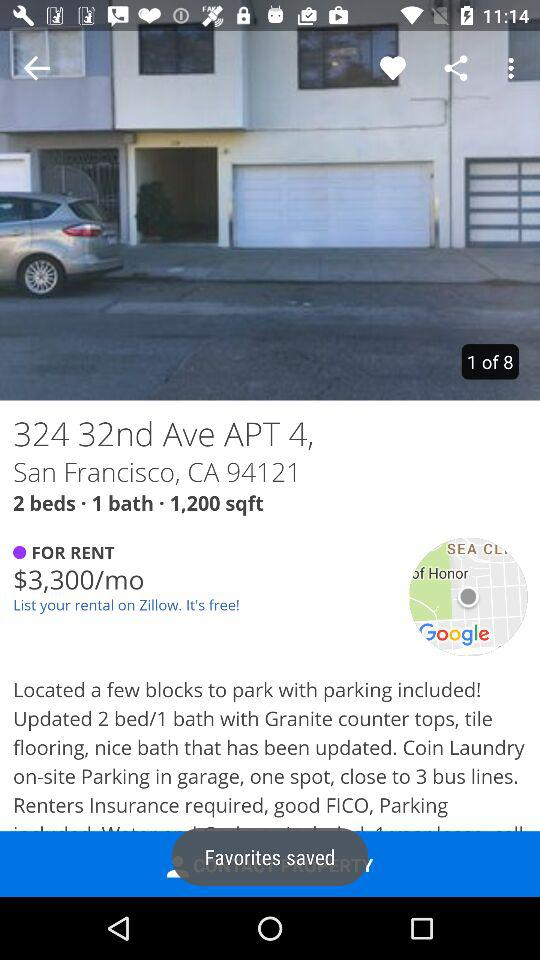How many more beds than baths does this apartment have?
Answer the question using a single word or phrase. 1 